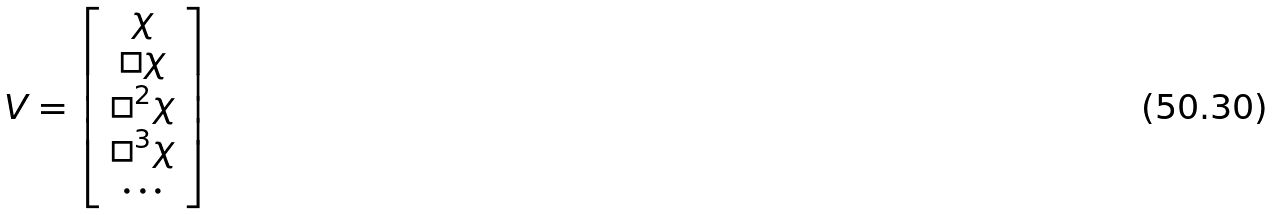Convert formula to latex. <formula><loc_0><loc_0><loc_500><loc_500>V = \left [ \begin{array} { c } \chi \\ \Box \chi \\ \Box ^ { 2 } \chi \\ \Box ^ { 3 } \chi \\ \cdots \end{array} \right ]</formula> 